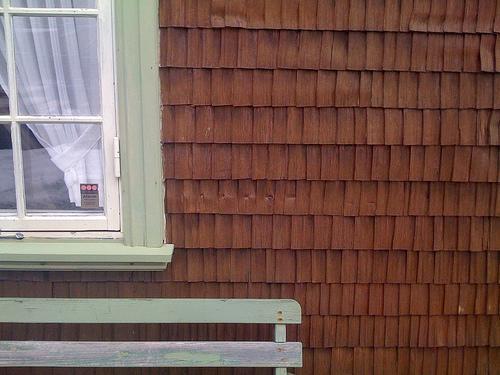How many windows are in this photo?
Give a very brief answer. 1. 